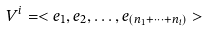Convert formula to latex. <formula><loc_0><loc_0><loc_500><loc_500>V ^ { i } = < e _ { 1 } , e _ { 2 } , \dots , e _ { ( n _ { 1 } + \dots + n _ { i } ) } ></formula> 